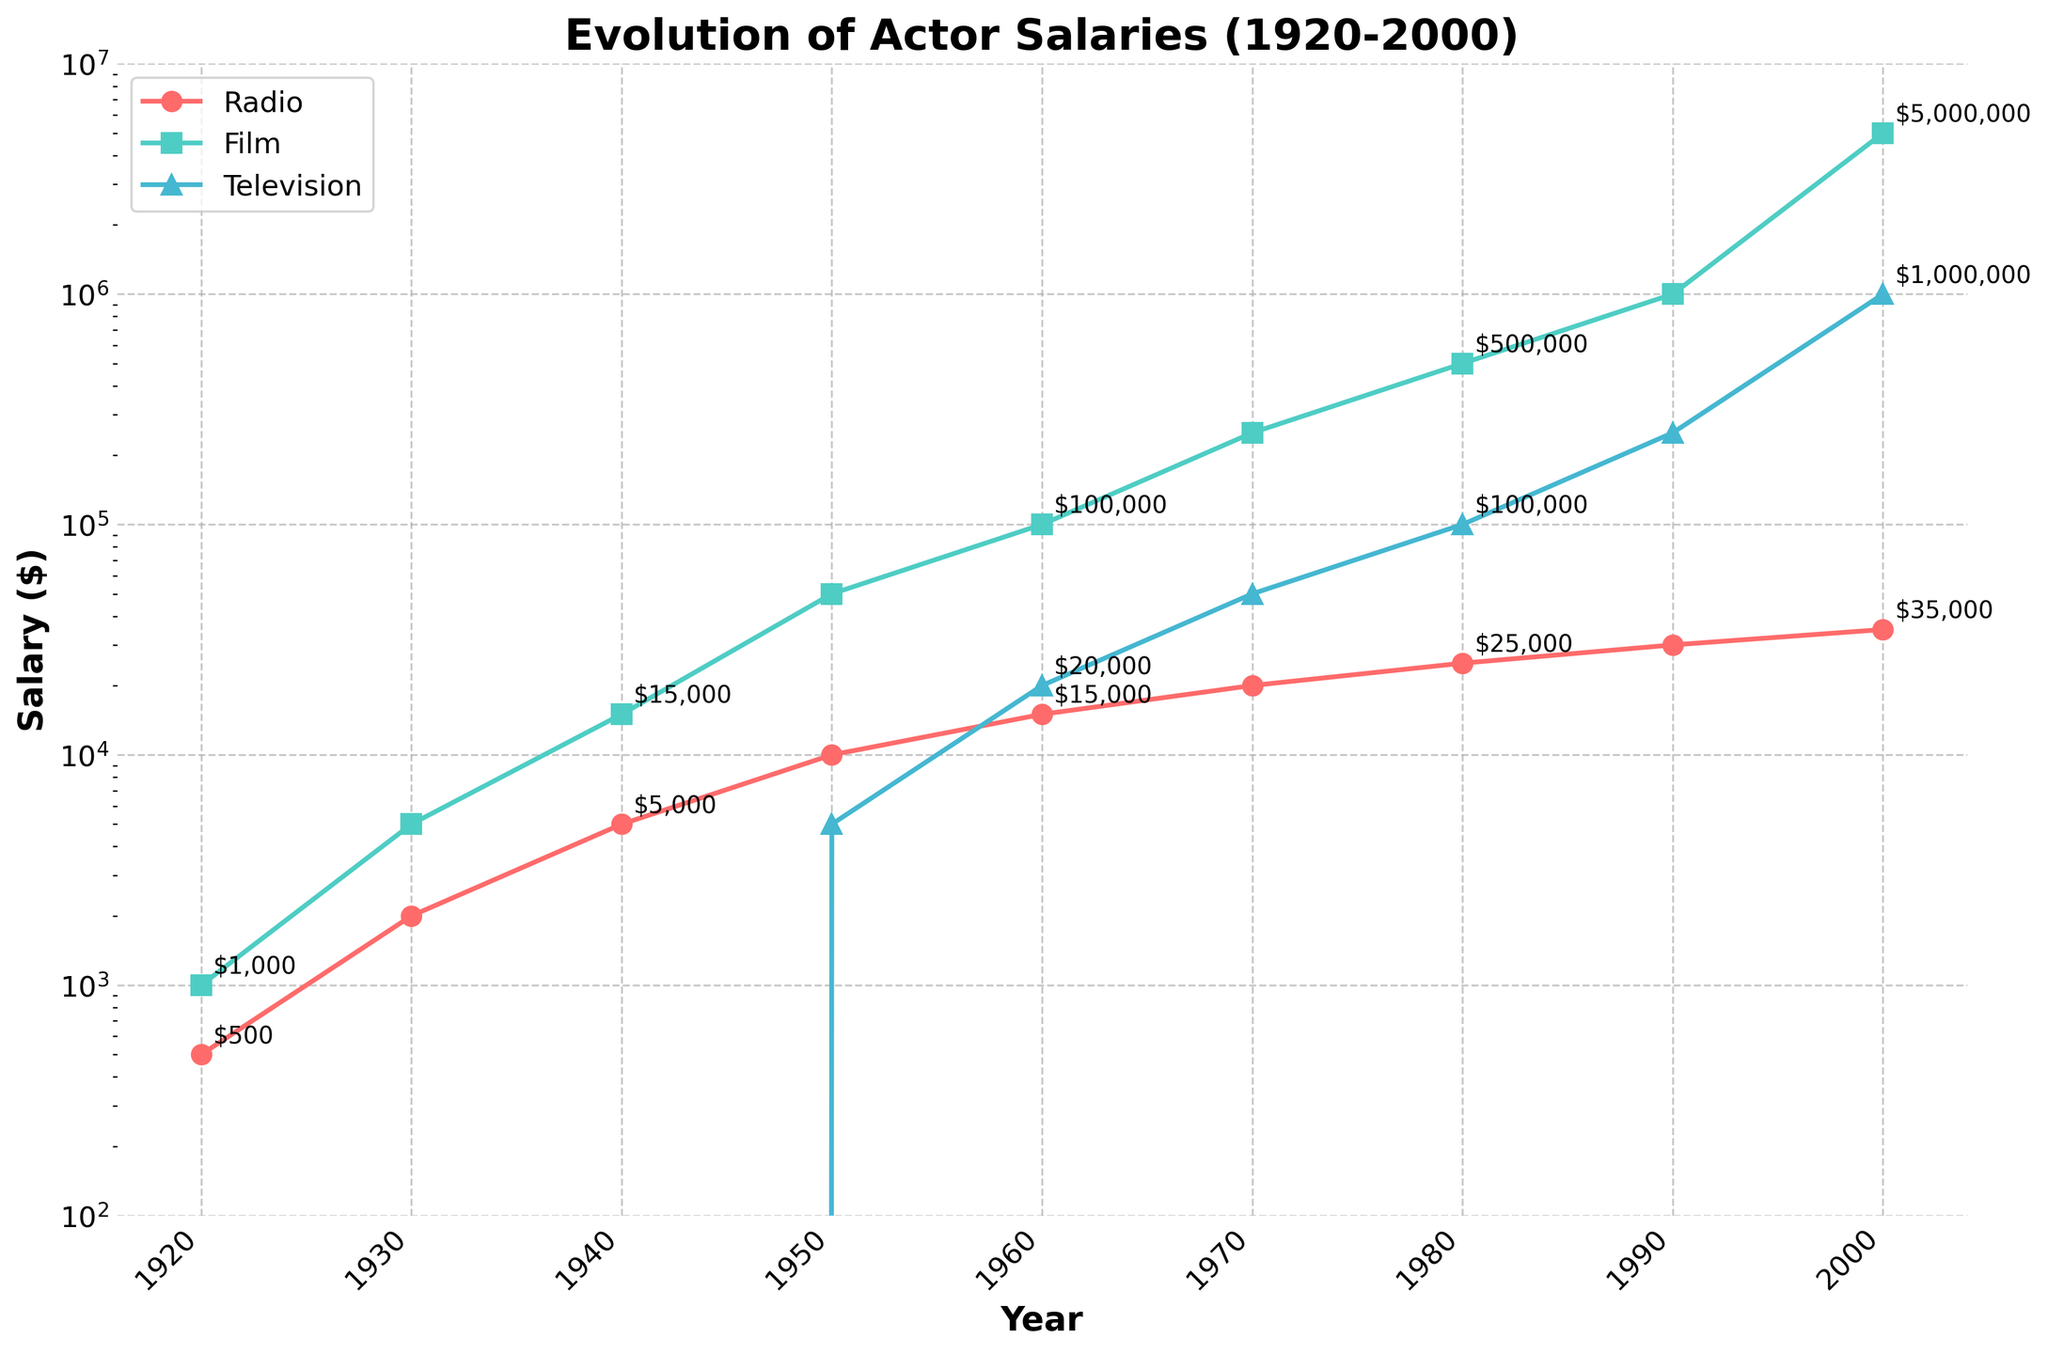What was the approximate salary increase for a radio actor from 1920 to 1950? The salary for a radio actor in 1920 was $500, and in 1950 it was $10,000. The increase can be calculated as $10,000 - $500 = $9,500.
Answer: $9,500 Between which two decades did film actor salaries see the highest jump? The largest jump is observed between 1990 and 2000. In 1990, the salary was $1,000,000, and in 2000, it rose to $5,000,000, indicating a $4,000,000 increase.
Answer: 1990-2000 How does the 1980 television actor salary compare with the 1970 film actor salary? The television actor salary in 1980 was $100,000, while the film actor salary in 1970 was $250,000. Thus, the 1970 film actor salary was higher.
Answer: The 1970 film actor salary was higher Which industry shows salaries starting from zero and gradually increases by 1950? The television actor salary starts at $0 in 1920 and gradually increases, reaching $5,000 by 1950.
Answer: Television When did radio actor salaries cease to be the highest compared with film and television actor salaries? Film actor salaries surpassed radio actor salaries starting from the 1940s, with film actors earning $15,000 while radio actors earned $5,000.
Answer: 1940s What is the ratio of film actor salary to radio actor salary in 1960? The film actor salary in 1960 was $100,000 and the radio actor salary was $15,000. The ratio is $100,000 / $15,000 = 6.67.
Answer: 6.67 In which decade did the television actor salary first exceed $100,000? The television actor salary first exceeds $100,000 in the 1980s, reaching exactly $100,000 in the year 1980.
Answer: 1980s Compare the growth trends of television and radio actor salaries from 1950 to 2000. Between 1950 and 2000, television actor salaries increased from $5,000 to $1,000,000 showing a rapid rise. During the same period, radio actor salaries grew from $10,000 to $35,000 showing a much slower increase.
Answer: Television grew faster than radio Identify the years where the annotated salary values for all three industries are closest to each other. In 1950, the salaries are $10,000 for radio, $50,000 for film, and $5,000 for television, showing the closest values among the three compared to other years.
Answer: 1950 How many times did the film actor salary increase from 1920 to 1930? The film actor salary was $1,000 in 1920 and $5,000 in 1930. The increase is $5,000 / $1,000 = 5 times.
Answer: 5 times 